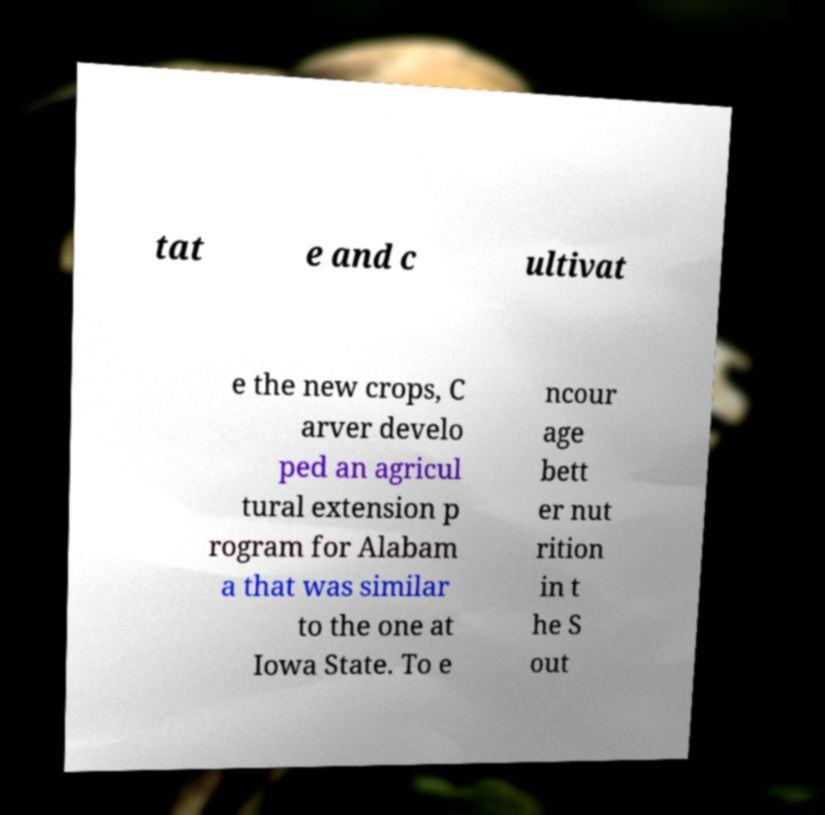There's text embedded in this image that I need extracted. Can you transcribe it verbatim? tat e and c ultivat e the new crops, C arver develo ped an agricul tural extension p rogram for Alabam a that was similar to the one at Iowa State. To e ncour age bett er nut rition in t he S out 